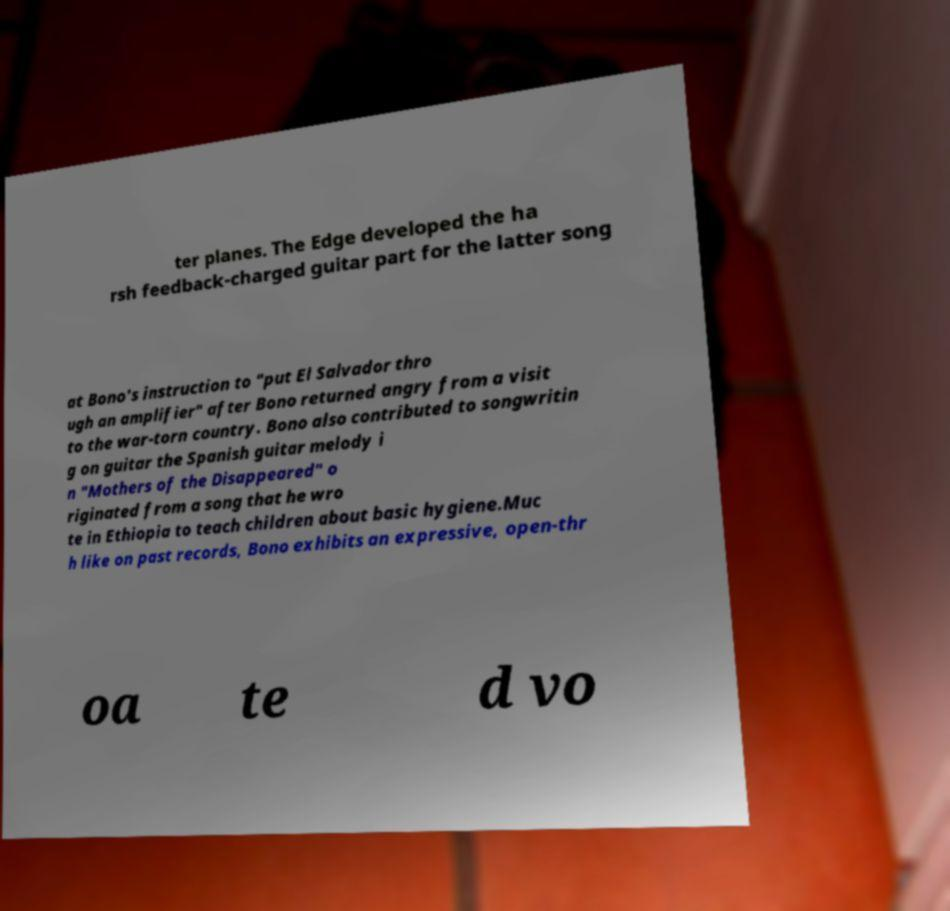I need the written content from this picture converted into text. Can you do that? ter planes. The Edge developed the ha rsh feedback-charged guitar part for the latter song at Bono's instruction to "put El Salvador thro ugh an amplifier" after Bono returned angry from a visit to the war-torn country. Bono also contributed to songwritin g on guitar the Spanish guitar melody i n "Mothers of the Disappeared" o riginated from a song that he wro te in Ethiopia to teach children about basic hygiene.Muc h like on past records, Bono exhibits an expressive, open-thr oa te d vo 